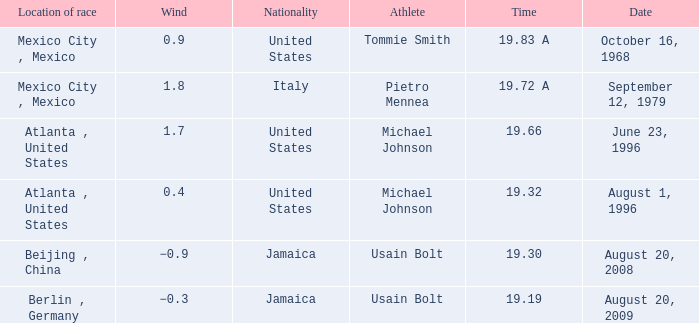What's the wind when the time was 19.32? 0.4. 